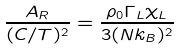Convert formula to latex. <formula><loc_0><loc_0><loc_500><loc_500>\frac { A _ { R } } { ( C / T ) ^ { 2 } } = \frac { \rho _ { 0 } \Gamma _ { L } \chi _ { L } } { 3 ( N k _ { B } ) ^ { 2 } }</formula> 